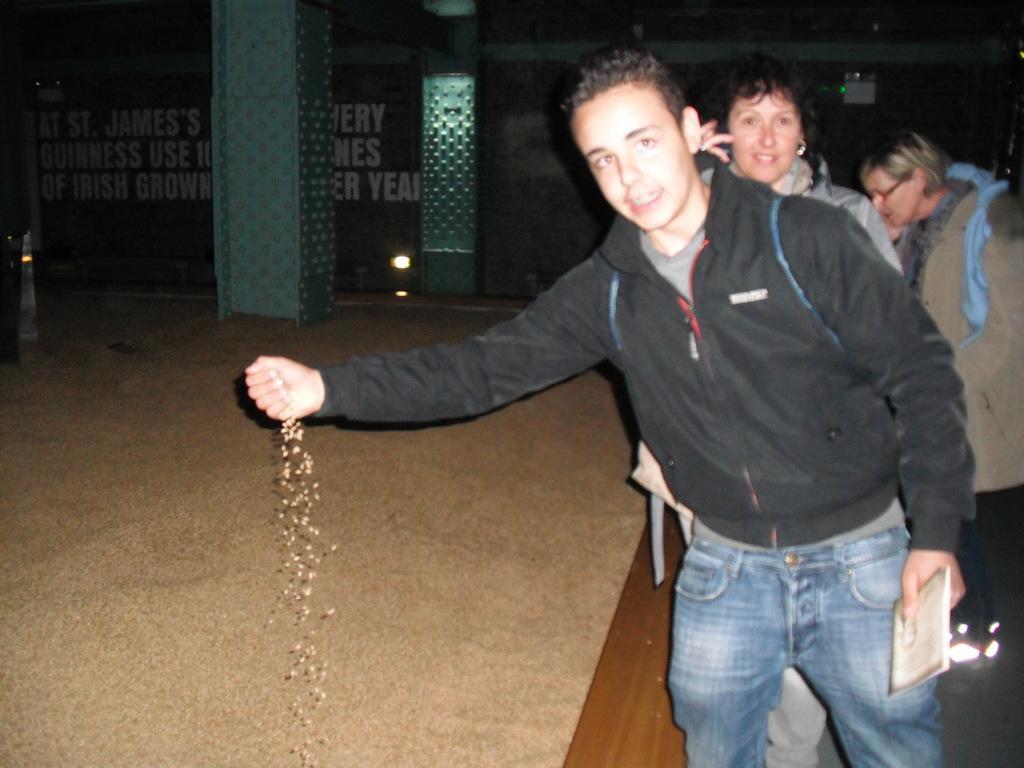How would you summarize this image in a sentence or two? Here we can see three persons and he is holding a book with his hand. This is floor. In the background we can see pillars, lights, and a wall. 